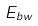Convert formula to latex. <formula><loc_0><loc_0><loc_500><loc_500>E _ { b w }</formula> 